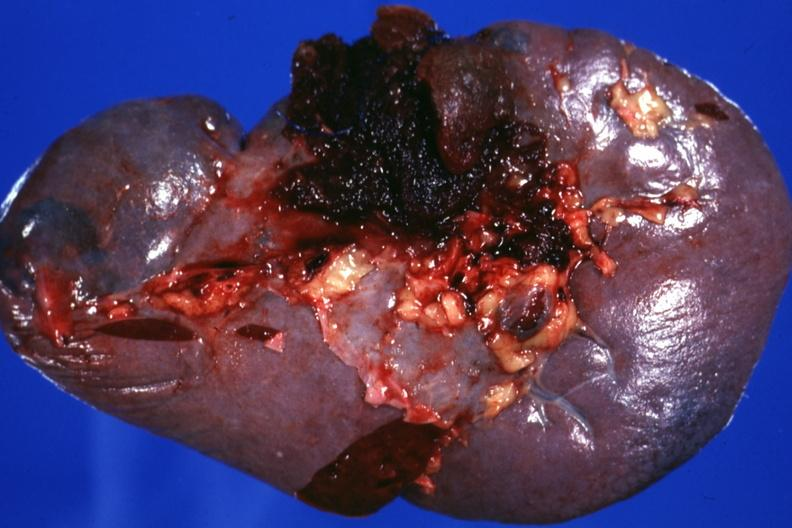s traumatic rupture present?
Answer the question using a single word or phrase. Yes 